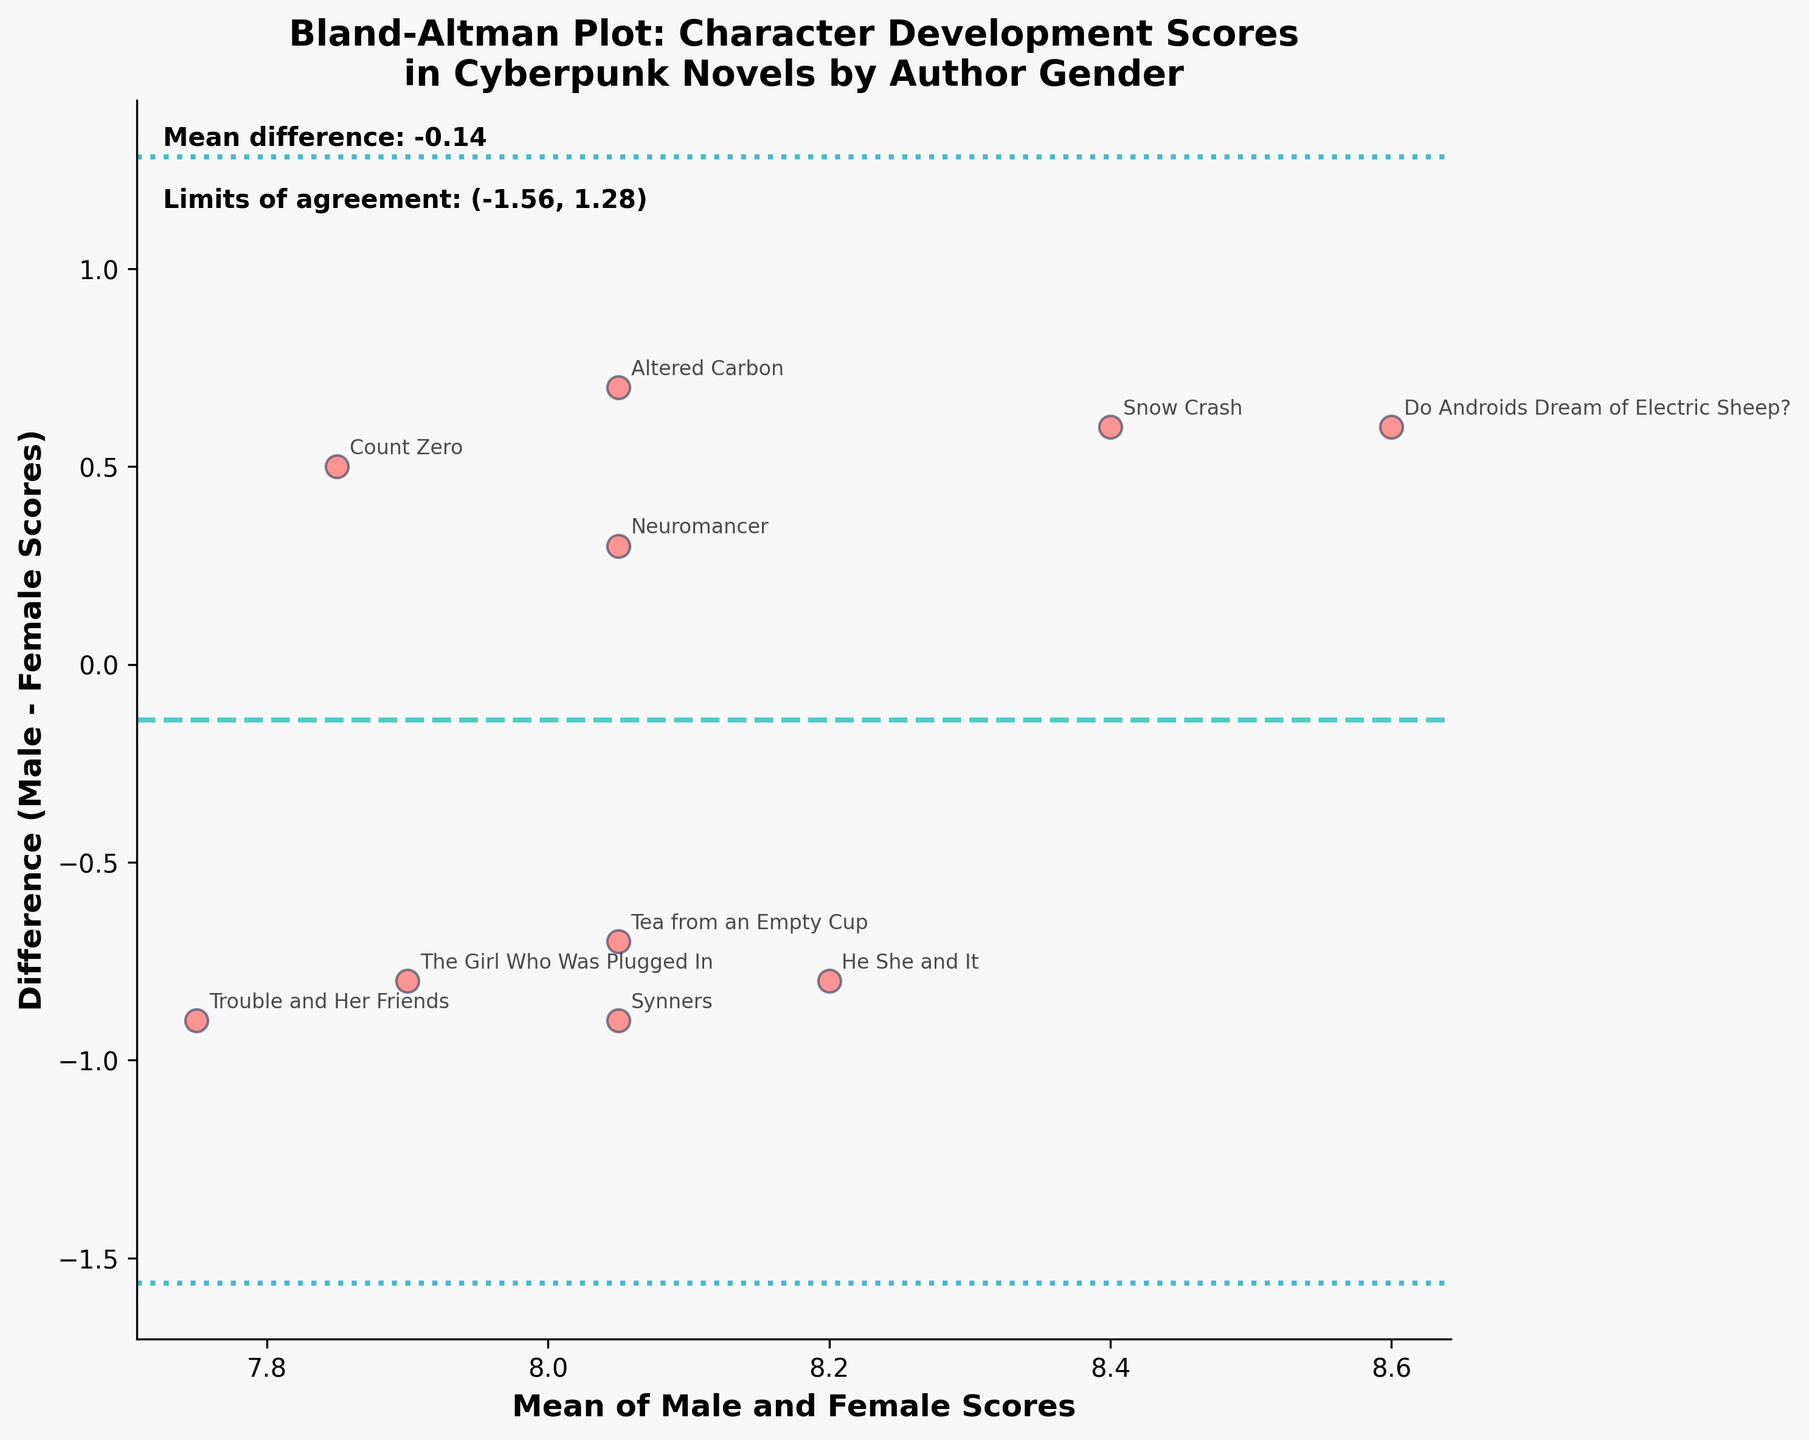What is the title of the plot? The title is located at the top center of the plot. It reads, "Bland-Altman Plot: Character Development Scores\nin Cyberpunk Novels by Author Gender."
Answer: "Bland-Altman Plot: Character Development Scores\nin Cyberpunk Novels by Author Gender" What is the color of the points representing differences between male and female scores? The points on the plot are represented in a noticeable visual color. They are colored in a shade of red with an edge color of dark purple.
Answer: Red What are the axes labels in the plot? The labels for the X and Y axes are written in bold below and to the left of the plot. The X-axis label reads "Mean of Male and Female Scores," and the Y-axis label reads "Difference (Male - Female Scores)."
Answer: X-axis: Mean of Male and Female Scores, Y-axis: Difference (Male - Female Scores) What is the mean difference between male and female scores? The mean difference is indicated by a horizontal dashed line in the plot and is also explicitly stated in a text box at the top-left corner of the plot. The mean difference value is approximately 0.19.
Answer: 0.19 What novels have the greatest positive and negative differences between male and female scores? By observing the vertical distances from the zero-difference line: "Do Androids Dream of Electric Sheep?" has the greatest positive difference, while "Altered Carbon" has the greatest negative difference.
Answer: Positive: "Do Androids Dream of Electric Sheep?", Negative: "Altered Carbon" What are the limits of agreement for the differences between scores? The limits of agreement are provided as horizontal dotted lines on the plot and are also mentioned in the text at the top-left corner. The limits are approximately (-0.62, 1.00).
Answer: (-0.62, 1.00) Which data point corresponds to the novel "Neuromancer"? The annotation next to a specific point corresponds to "Neuromancer." By finding the label, we can see it is near a mean score of around 8.05 and a difference close to 0.3.
Answer: Mean ~ 8.05, Difference ~ 0.3 How many data points are there in the plot? Each data point represents a novel; counting the points gives the total number of novels. There are annotations next to each point which total ten.
Answer: Ten Explain why the plot shows both the mean of male and female scores and the difference between them. The Bland-Altman plot visually represents the agreement between two sets of scores by plotting the mean of the two against their difference. This helps identify any systematic differences and the variability. For example, whether male or female authors consistently score higher or lower.
Answer: Shows agreement and variability Is there an obvious trend that male-authored novels score higher or lower than female-authored novels? By examining whether points mostly fall above or below the zero difference line, we can infer a trend. Most points hover around the line, with no extreme systematic bias towards either higher or lower scores for male-authored or female-authored novels.
Answer: No obvious trend 